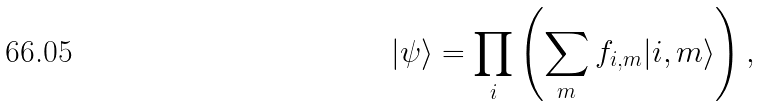Convert formula to latex. <formula><loc_0><loc_0><loc_500><loc_500>| \psi \rangle = \prod _ { i } \left ( \sum _ { m } f _ { i , m } | i , m \rangle \right ) ,</formula> 